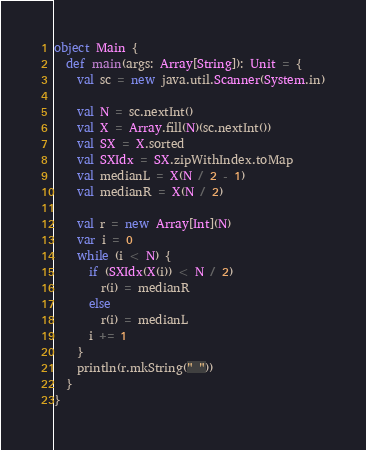Convert code to text. <code><loc_0><loc_0><loc_500><loc_500><_Scala_>object Main {
  def main(args: Array[String]): Unit = {
    val sc = new java.util.Scanner(System.in)
    
    val N = sc.nextInt()
    val X = Array.fill(N)(sc.nextInt())
    val SX = X.sorted
    val SXIdx = SX.zipWithIndex.toMap
    val medianL = X(N / 2 - 1)
    val medianR = X(N / 2)
    
    val r = new Array[Int](N)
    var i = 0
    while (i < N) {
      if (SXIdx(X(i)) < N / 2)
        r(i) = medianR
      else
        r(i) = medianL
      i += 1
    }
    println(r.mkString(" "))
  }
}
</code> 